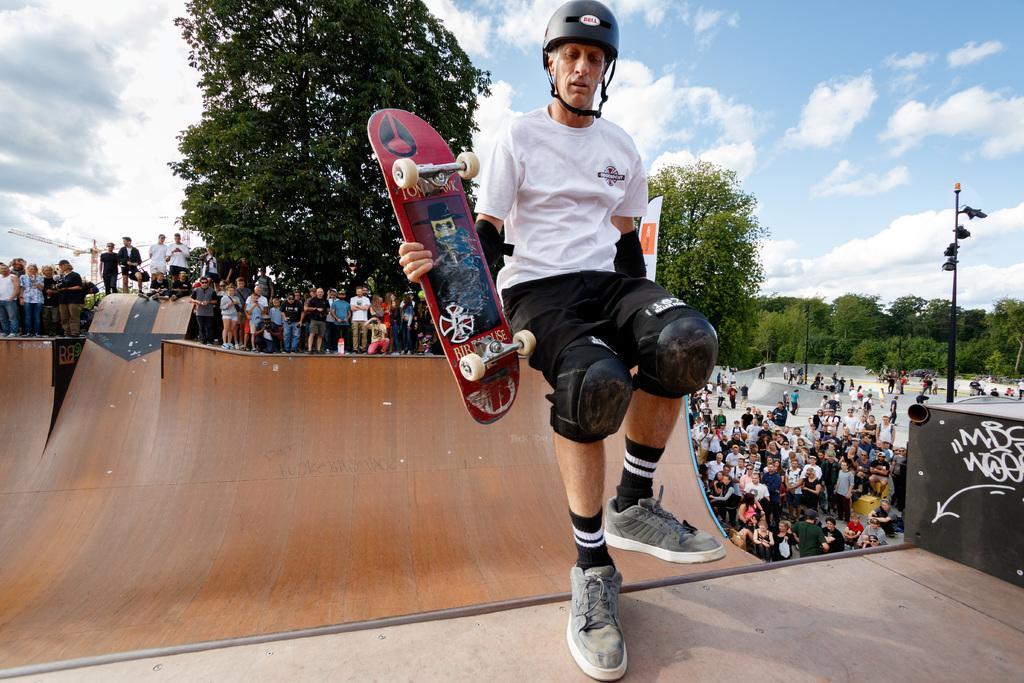Describe this image in one or two sentences. In this image we can see many people. There are many trees in the image. We can see the clouds in the sky. There is an object at the left side of the image. There is some text on an object at the right side of the image. We can see a person holding a skateboard in his hand. There are few poles in the image. 